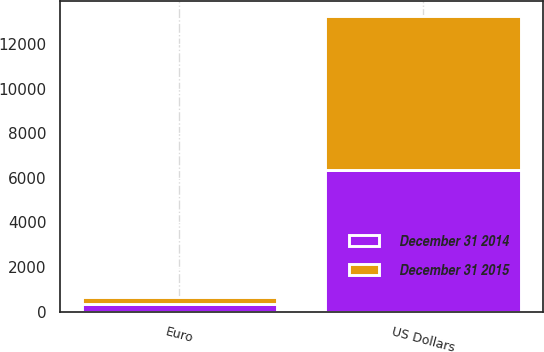Convert chart to OTSL. <chart><loc_0><loc_0><loc_500><loc_500><stacked_bar_chart><ecel><fcel>US Dollars<fcel>Euro<nl><fcel>December 31 2015<fcel>6891<fcel>305<nl><fcel>December 31 2014<fcel>6351<fcel>343<nl></chart> 